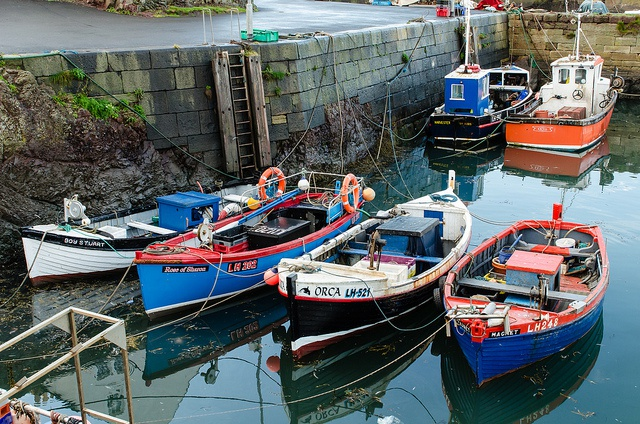Describe the objects in this image and their specific colors. I can see boat in gray, black, navy, and lightgray tones, boat in gray, black, lightgray, and darkgray tones, boat in gray, black, blue, and darkgray tones, boat in gray, black, lightgray, darkgray, and blue tones, and boat in gray, lightgray, red, and darkgray tones in this image. 